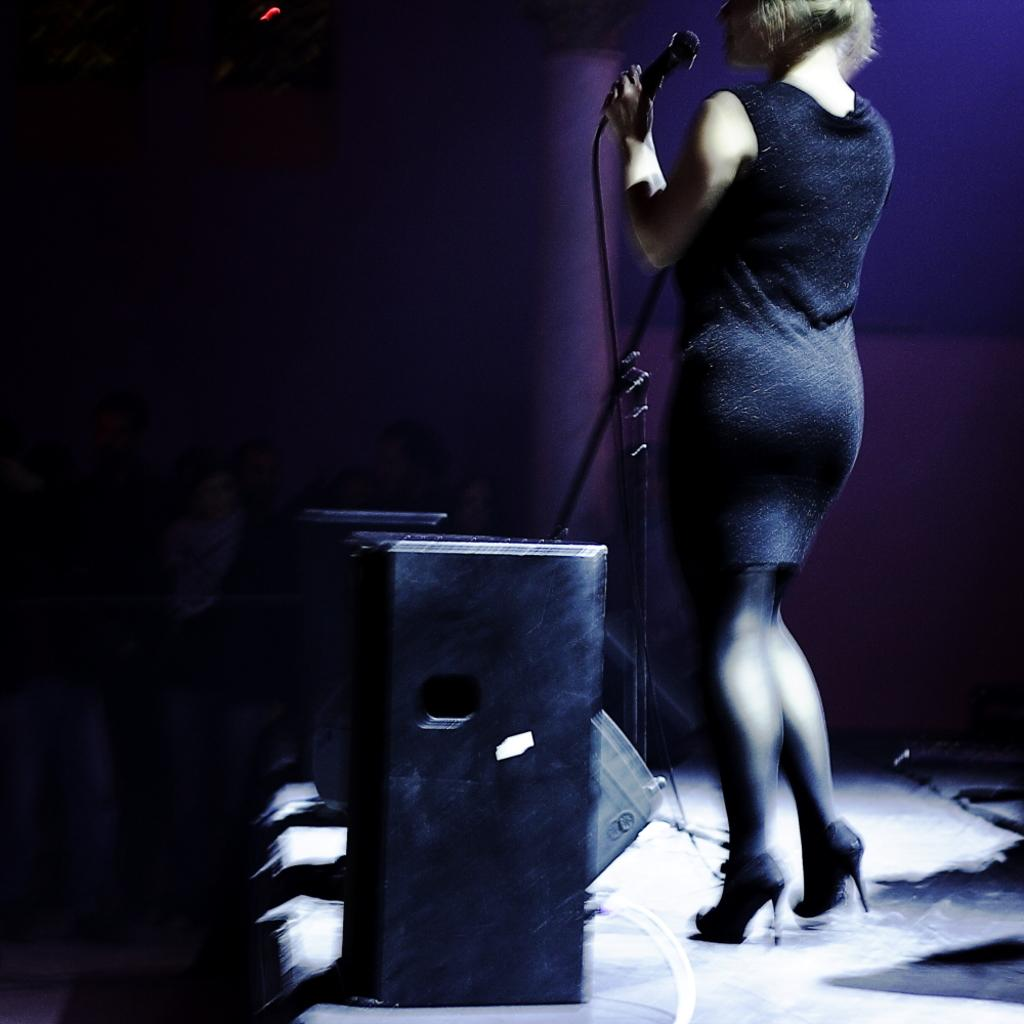What is the woman doing in the image? The woman is standing on the dais in the image. What object is the woman holding? The woman is holding a microphone. What other equipment is present on the dais? There is a speaker on the dais. How would you describe the overall appearance of the image? The backdrop of the image is dark. Is the woman sinking into quicksand in the image? No, there is no quicksand present in the image. How many pages can be seen in the image? There are no pages visible in the image. 